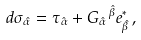<formula> <loc_0><loc_0><loc_500><loc_500>d \sigma _ { \hat { \alpha } } = \tau _ { \hat { \alpha } } + G _ { \hat { \alpha } } \, ^ { \hat { \beta } } e ^ { \ast } _ { \hat { \beta } } \, ,</formula> 